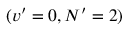Convert formula to latex. <formula><loc_0><loc_0><loc_500><loc_500>( v ^ { \prime } = 0 , N ^ { \prime } = 2 )</formula> 